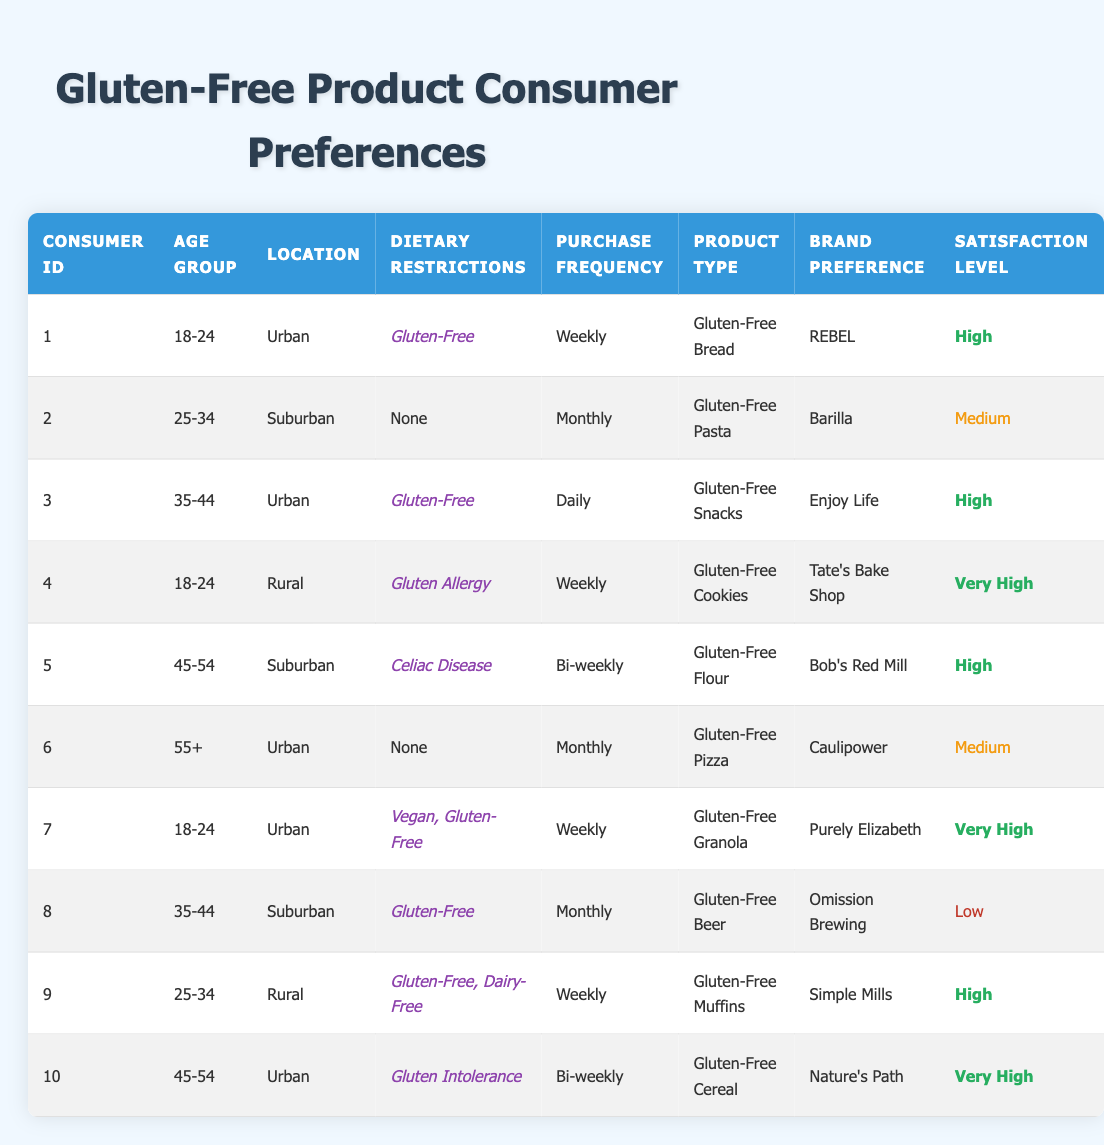What is the product type that Consumer ID 4 prefers? Look at the row with Consumer ID 4, where the product type is listed as "Gluten-Free Cookies."
Answer: Gluten-Free Cookies How many consumers have a satisfaction level of "Very High"? Review the satisfaction levels in the table. The consumers with the satisfaction level of "Very High" are Consumer ID 4, Consumer ID 7, and Consumer ID 10. Therefore, there are three consumers.
Answer: 3 Which product type has the highest satisfaction level among consumers in the "18-24" age group? Check the satisfaction levels for consumers in the "18-24" age group. Consumer ID 4 has "Very High" for "Gluten-Free Cookies," and Consumer ID 1 has "High" for "Gluten-Free Bread." Thus, the highest satisfaction is "Very High" for Gluten-Free Cookies.
Answer: Gluten-Free Cookies Is there a consumer in the "55+" age group who has gluten dietary restrictions? Look for any consumer in the "55+" age group with dietary restrictions listed. Consumer ID 6 falls under the "55+" category and lists "None" as dietary restrictions. Therefore, the answer is no.
Answer: No How does the purchase frequency of consumers with gluten allergies compare to those with celiac disease? Count the purchase frequency for consumers with gluten allergy (Consumer ID 4, who purchases weekly) and celiac disease (Consumer ID 5, who purchases bi-weekly). Comparing the frequencies shows that consumers with gluten allergy purchase more frequently (weekly) than those with celiac disease (bi-weekly).
Answer: Weekly > Bi-weekly What percentage of consumers are from an urban location? From the table, count the consumers in the urban location: Consumer ID 1, Consumer ID 3, Consumer ID 6, Consumer ID 7, and Consumer ID 10 (total of 5). There are 10 consumers total, indicating 50% live in urban locations (5 out of 10 = 50%).
Answer: 50% Which brand has the lowest satisfaction level and what is the product type? In the table, find the consumer with the lowest satisfaction level of "Low," which corresponds to Consumer ID 8. Their product type is "Gluten-Free Beer," and the brand preference is "Omission Brewing."
Answer: Gluten-Free Beer, Omission Brewing How many consumers have dietary restrictions other than gluten? Identify consumers with dietary restrictions: Consumer ID 2 has "None," Consumer ID 6 has "None," and Consumer ID 9 has "Gluten-Free, Dairy-Free." The total here indicates that 2 out of 10 have no gluten restrictions, lessening their restriction count.
Answer: 2 